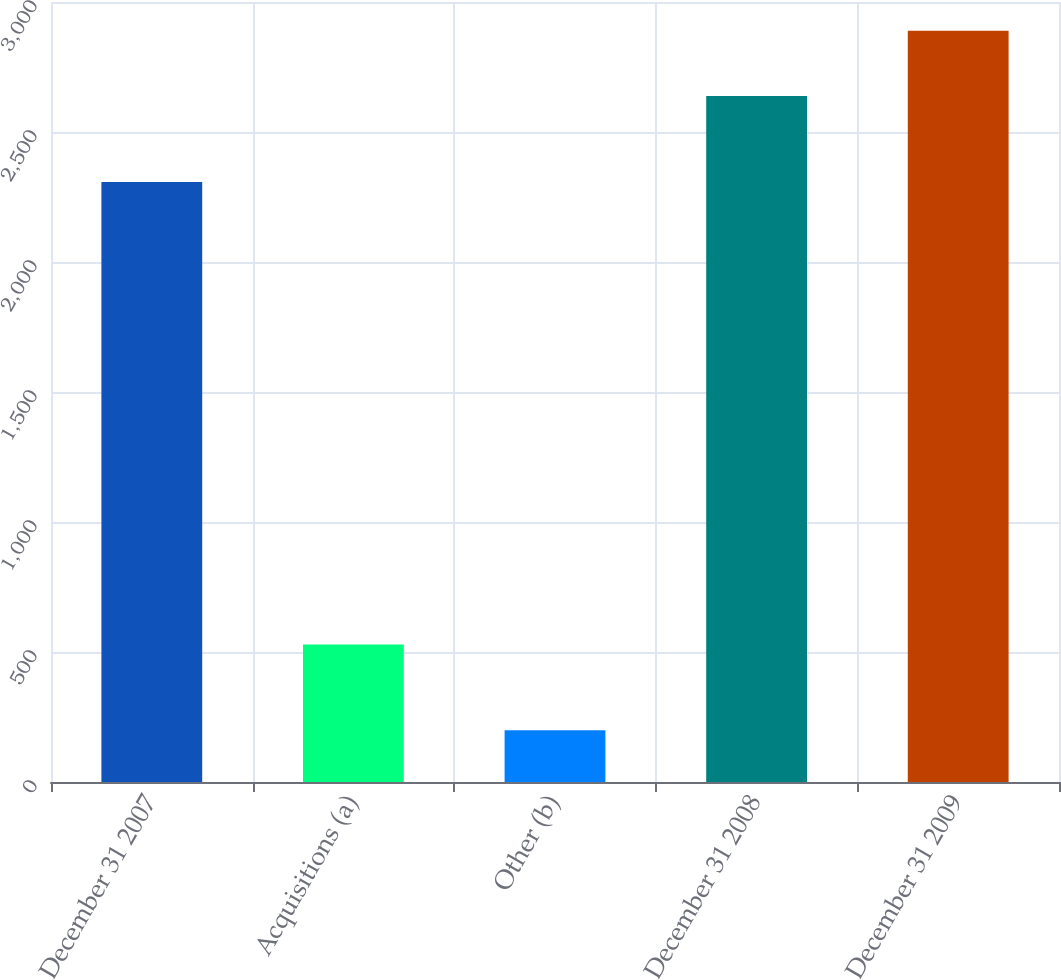Convert chart. <chart><loc_0><loc_0><loc_500><loc_500><bar_chart><fcel>December 31 2007<fcel>Acquisitions (a)<fcel>Other (b)<fcel>December 31 2008<fcel>December 31 2009<nl><fcel>2308<fcel>529<fcel>199<fcel>2638<fcel>2889.1<nl></chart> 